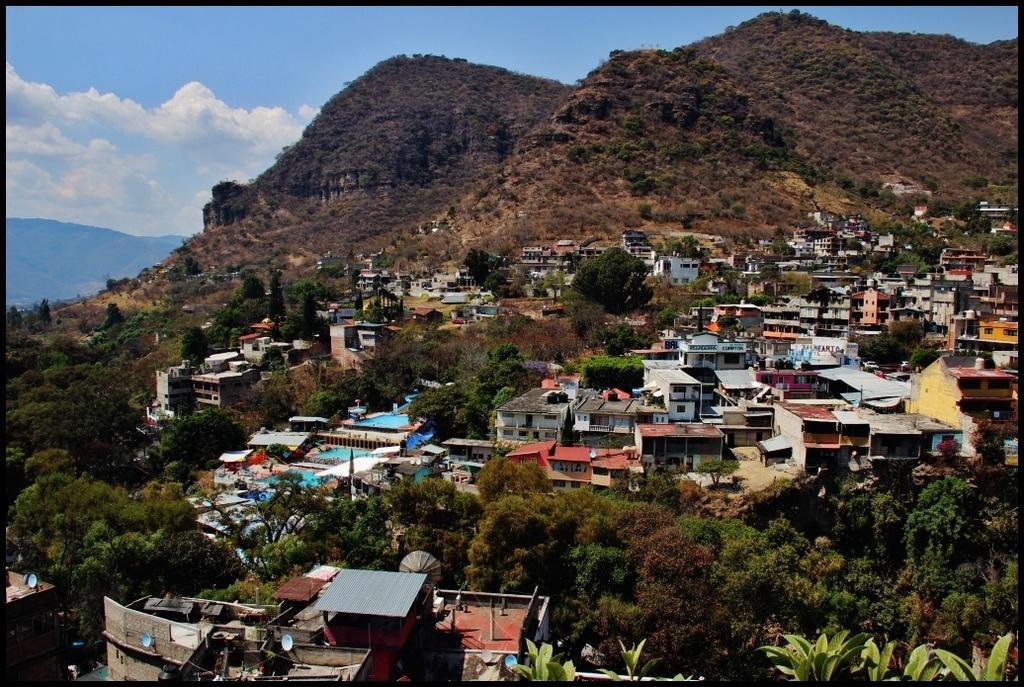Can you describe this image briefly? In the image there are many houses with roofs, walls and poles. And also there are many trees. Behind them there are hills with trees. And at the top of the image there is a sky with clouds. 